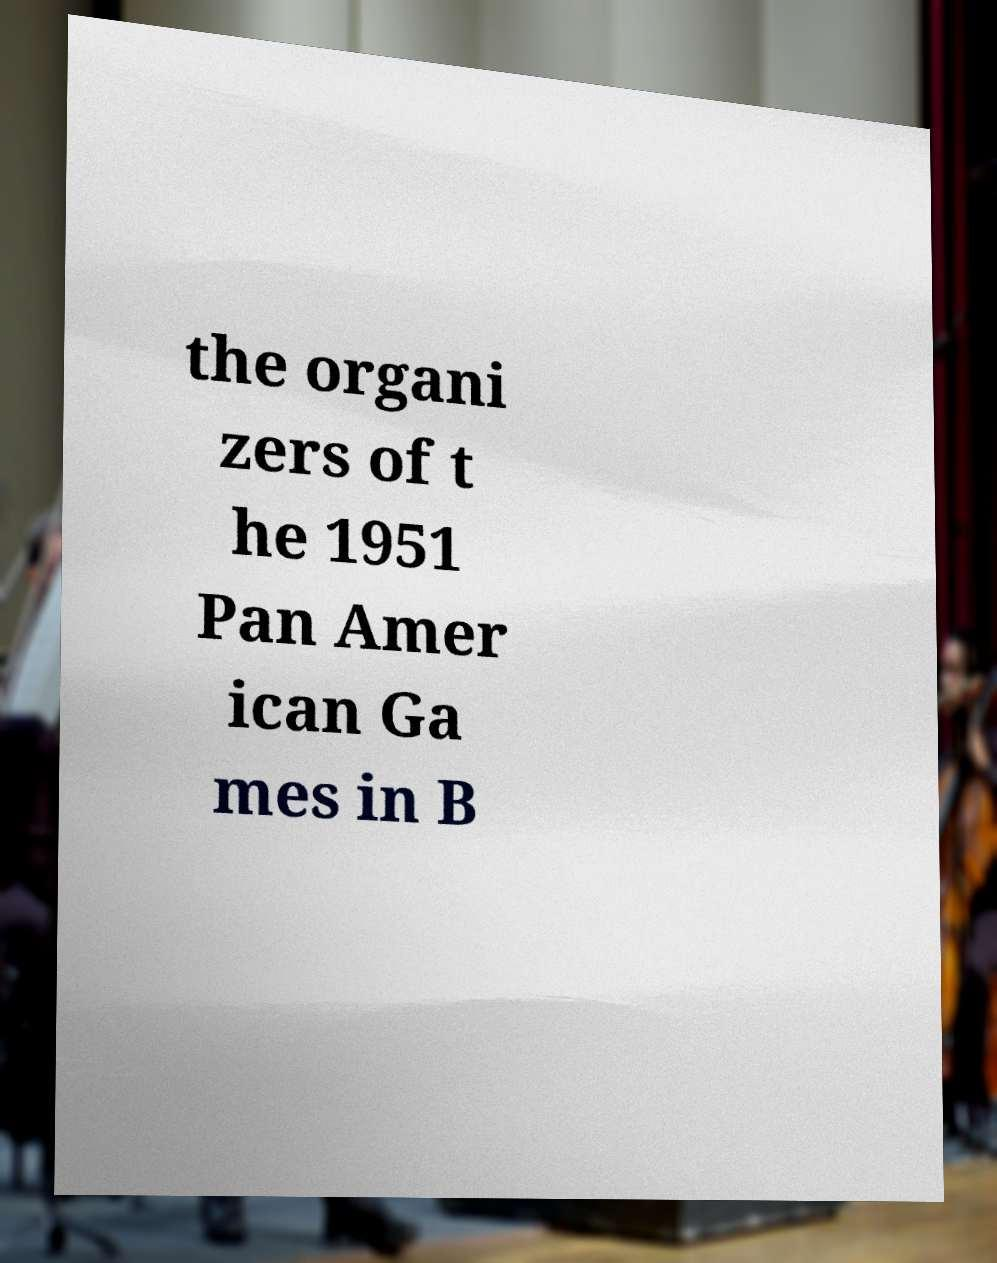Can you read and provide the text displayed in the image?This photo seems to have some interesting text. Can you extract and type it out for me? the organi zers of t he 1951 Pan Amer ican Ga mes in B 